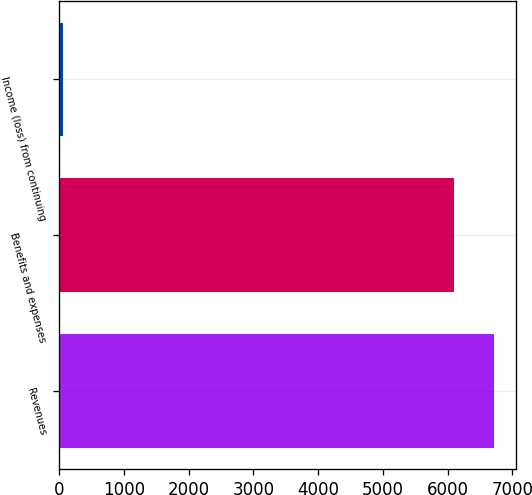Convert chart. <chart><loc_0><loc_0><loc_500><loc_500><bar_chart><fcel>Revenues<fcel>Benefits and expenses<fcel>Income (loss) from continuing<nl><fcel>6712.2<fcel>6102<fcel>58<nl></chart> 